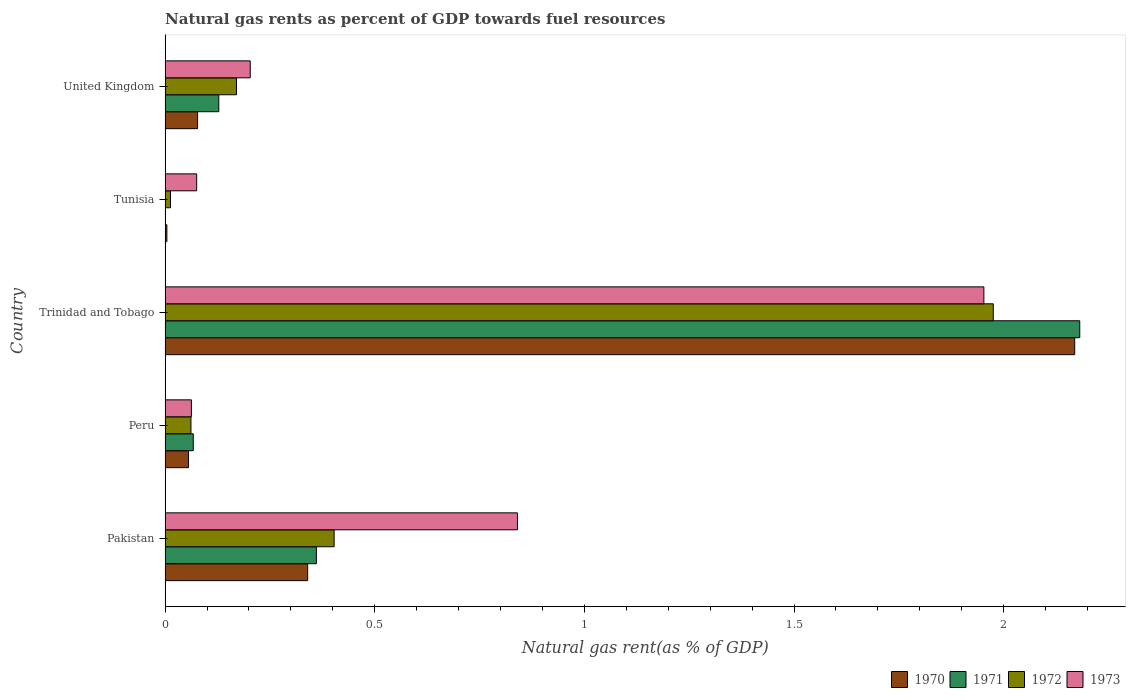How many different coloured bars are there?
Give a very brief answer. 4. How many bars are there on the 3rd tick from the top?
Make the answer very short. 4. How many bars are there on the 1st tick from the bottom?
Offer a very short reply. 4. What is the label of the 2nd group of bars from the top?
Your answer should be compact. Tunisia. What is the natural gas rent in 1971 in Peru?
Your response must be concise. 0.07. Across all countries, what is the maximum natural gas rent in 1973?
Your response must be concise. 1.95. Across all countries, what is the minimum natural gas rent in 1973?
Give a very brief answer. 0.06. In which country was the natural gas rent in 1971 maximum?
Provide a short and direct response. Trinidad and Tobago. In which country was the natural gas rent in 1972 minimum?
Offer a very short reply. Tunisia. What is the total natural gas rent in 1972 in the graph?
Provide a short and direct response. 2.62. What is the difference between the natural gas rent in 1972 in Peru and that in United Kingdom?
Offer a very short reply. -0.11. What is the difference between the natural gas rent in 1971 in Tunisia and the natural gas rent in 1972 in Peru?
Your response must be concise. -0.06. What is the average natural gas rent in 1973 per country?
Provide a short and direct response. 0.63. What is the difference between the natural gas rent in 1972 and natural gas rent in 1971 in Peru?
Ensure brevity in your answer.  -0.01. In how many countries, is the natural gas rent in 1971 greater than 0.9 %?
Provide a short and direct response. 1. What is the ratio of the natural gas rent in 1971 in Pakistan to that in Trinidad and Tobago?
Ensure brevity in your answer.  0.17. Is the difference between the natural gas rent in 1972 in Pakistan and Peru greater than the difference between the natural gas rent in 1971 in Pakistan and Peru?
Offer a terse response. Yes. What is the difference between the highest and the second highest natural gas rent in 1971?
Keep it short and to the point. 1.82. What is the difference between the highest and the lowest natural gas rent in 1970?
Offer a terse response. 2.17. In how many countries, is the natural gas rent in 1970 greater than the average natural gas rent in 1970 taken over all countries?
Provide a succinct answer. 1. Does the graph contain grids?
Provide a succinct answer. No. How many legend labels are there?
Make the answer very short. 4. How are the legend labels stacked?
Offer a terse response. Horizontal. What is the title of the graph?
Your response must be concise. Natural gas rents as percent of GDP towards fuel resources. What is the label or title of the X-axis?
Your answer should be compact. Natural gas rent(as % of GDP). What is the label or title of the Y-axis?
Provide a short and direct response. Country. What is the Natural gas rent(as % of GDP) of 1970 in Pakistan?
Keep it short and to the point. 0.34. What is the Natural gas rent(as % of GDP) of 1971 in Pakistan?
Make the answer very short. 0.36. What is the Natural gas rent(as % of GDP) in 1972 in Pakistan?
Give a very brief answer. 0.4. What is the Natural gas rent(as % of GDP) of 1973 in Pakistan?
Make the answer very short. 0.84. What is the Natural gas rent(as % of GDP) of 1970 in Peru?
Provide a succinct answer. 0.06. What is the Natural gas rent(as % of GDP) in 1971 in Peru?
Offer a very short reply. 0.07. What is the Natural gas rent(as % of GDP) in 1972 in Peru?
Offer a terse response. 0.06. What is the Natural gas rent(as % of GDP) in 1973 in Peru?
Your answer should be very brief. 0.06. What is the Natural gas rent(as % of GDP) in 1970 in Trinidad and Tobago?
Provide a succinct answer. 2.17. What is the Natural gas rent(as % of GDP) of 1971 in Trinidad and Tobago?
Your answer should be compact. 2.18. What is the Natural gas rent(as % of GDP) of 1972 in Trinidad and Tobago?
Your response must be concise. 1.98. What is the Natural gas rent(as % of GDP) of 1973 in Trinidad and Tobago?
Your answer should be compact. 1.95. What is the Natural gas rent(as % of GDP) in 1970 in Tunisia?
Provide a succinct answer. 0. What is the Natural gas rent(as % of GDP) of 1971 in Tunisia?
Your answer should be very brief. 0. What is the Natural gas rent(as % of GDP) in 1972 in Tunisia?
Your response must be concise. 0.01. What is the Natural gas rent(as % of GDP) of 1973 in Tunisia?
Give a very brief answer. 0.08. What is the Natural gas rent(as % of GDP) in 1970 in United Kingdom?
Your response must be concise. 0.08. What is the Natural gas rent(as % of GDP) in 1971 in United Kingdom?
Your answer should be very brief. 0.13. What is the Natural gas rent(as % of GDP) in 1972 in United Kingdom?
Provide a succinct answer. 0.17. What is the Natural gas rent(as % of GDP) in 1973 in United Kingdom?
Keep it short and to the point. 0.2. Across all countries, what is the maximum Natural gas rent(as % of GDP) in 1970?
Your answer should be compact. 2.17. Across all countries, what is the maximum Natural gas rent(as % of GDP) of 1971?
Offer a very short reply. 2.18. Across all countries, what is the maximum Natural gas rent(as % of GDP) of 1972?
Your answer should be very brief. 1.98. Across all countries, what is the maximum Natural gas rent(as % of GDP) of 1973?
Offer a terse response. 1.95. Across all countries, what is the minimum Natural gas rent(as % of GDP) in 1970?
Your answer should be compact. 0. Across all countries, what is the minimum Natural gas rent(as % of GDP) of 1971?
Offer a very short reply. 0. Across all countries, what is the minimum Natural gas rent(as % of GDP) of 1972?
Your answer should be very brief. 0.01. Across all countries, what is the minimum Natural gas rent(as % of GDP) in 1973?
Offer a very short reply. 0.06. What is the total Natural gas rent(as % of GDP) in 1970 in the graph?
Give a very brief answer. 2.65. What is the total Natural gas rent(as % of GDP) of 1971 in the graph?
Give a very brief answer. 2.74. What is the total Natural gas rent(as % of GDP) of 1972 in the graph?
Offer a very short reply. 2.62. What is the total Natural gas rent(as % of GDP) of 1973 in the graph?
Your response must be concise. 3.13. What is the difference between the Natural gas rent(as % of GDP) in 1970 in Pakistan and that in Peru?
Give a very brief answer. 0.28. What is the difference between the Natural gas rent(as % of GDP) in 1971 in Pakistan and that in Peru?
Your answer should be compact. 0.29. What is the difference between the Natural gas rent(as % of GDP) in 1972 in Pakistan and that in Peru?
Make the answer very short. 0.34. What is the difference between the Natural gas rent(as % of GDP) of 1973 in Pakistan and that in Peru?
Give a very brief answer. 0.78. What is the difference between the Natural gas rent(as % of GDP) of 1970 in Pakistan and that in Trinidad and Tobago?
Your answer should be very brief. -1.83. What is the difference between the Natural gas rent(as % of GDP) of 1971 in Pakistan and that in Trinidad and Tobago?
Offer a terse response. -1.82. What is the difference between the Natural gas rent(as % of GDP) of 1972 in Pakistan and that in Trinidad and Tobago?
Give a very brief answer. -1.57. What is the difference between the Natural gas rent(as % of GDP) in 1973 in Pakistan and that in Trinidad and Tobago?
Offer a very short reply. -1.11. What is the difference between the Natural gas rent(as % of GDP) in 1970 in Pakistan and that in Tunisia?
Your response must be concise. 0.34. What is the difference between the Natural gas rent(as % of GDP) of 1971 in Pakistan and that in Tunisia?
Your answer should be very brief. 0.36. What is the difference between the Natural gas rent(as % of GDP) in 1972 in Pakistan and that in Tunisia?
Ensure brevity in your answer.  0.39. What is the difference between the Natural gas rent(as % of GDP) in 1973 in Pakistan and that in Tunisia?
Your answer should be very brief. 0.77. What is the difference between the Natural gas rent(as % of GDP) in 1970 in Pakistan and that in United Kingdom?
Your answer should be very brief. 0.26. What is the difference between the Natural gas rent(as % of GDP) in 1971 in Pakistan and that in United Kingdom?
Your response must be concise. 0.23. What is the difference between the Natural gas rent(as % of GDP) in 1972 in Pakistan and that in United Kingdom?
Give a very brief answer. 0.23. What is the difference between the Natural gas rent(as % of GDP) of 1973 in Pakistan and that in United Kingdom?
Your answer should be compact. 0.64. What is the difference between the Natural gas rent(as % of GDP) of 1970 in Peru and that in Trinidad and Tobago?
Offer a very short reply. -2.11. What is the difference between the Natural gas rent(as % of GDP) of 1971 in Peru and that in Trinidad and Tobago?
Keep it short and to the point. -2.11. What is the difference between the Natural gas rent(as % of GDP) in 1972 in Peru and that in Trinidad and Tobago?
Provide a succinct answer. -1.91. What is the difference between the Natural gas rent(as % of GDP) of 1973 in Peru and that in Trinidad and Tobago?
Keep it short and to the point. -1.89. What is the difference between the Natural gas rent(as % of GDP) of 1970 in Peru and that in Tunisia?
Your answer should be compact. 0.05. What is the difference between the Natural gas rent(as % of GDP) in 1971 in Peru and that in Tunisia?
Ensure brevity in your answer.  0.07. What is the difference between the Natural gas rent(as % of GDP) in 1972 in Peru and that in Tunisia?
Ensure brevity in your answer.  0.05. What is the difference between the Natural gas rent(as % of GDP) of 1973 in Peru and that in Tunisia?
Give a very brief answer. -0.01. What is the difference between the Natural gas rent(as % of GDP) in 1970 in Peru and that in United Kingdom?
Provide a short and direct response. -0.02. What is the difference between the Natural gas rent(as % of GDP) in 1971 in Peru and that in United Kingdom?
Keep it short and to the point. -0.06. What is the difference between the Natural gas rent(as % of GDP) in 1972 in Peru and that in United Kingdom?
Make the answer very short. -0.11. What is the difference between the Natural gas rent(as % of GDP) of 1973 in Peru and that in United Kingdom?
Provide a short and direct response. -0.14. What is the difference between the Natural gas rent(as % of GDP) in 1970 in Trinidad and Tobago and that in Tunisia?
Ensure brevity in your answer.  2.17. What is the difference between the Natural gas rent(as % of GDP) in 1971 in Trinidad and Tobago and that in Tunisia?
Your answer should be compact. 2.18. What is the difference between the Natural gas rent(as % of GDP) in 1972 in Trinidad and Tobago and that in Tunisia?
Your response must be concise. 1.96. What is the difference between the Natural gas rent(as % of GDP) in 1973 in Trinidad and Tobago and that in Tunisia?
Give a very brief answer. 1.88. What is the difference between the Natural gas rent(as % of GDP) of 1970 in Trinidad and Tobago and that in United Kingdom?
Give a very brief answer. 2.09. What is the difference between the Natural gas rent(as % of GDP) of 1971 in Trinidad and Tobago and that in United Kingdom?
Give a very brief answer. 2.05. What is the difference between the Natural gas rent(as % of GDP) in 1972 in Trinidad and Tobago and that in United Kingdom?
Your response must be concise. 1.8. What is the difference between the Natural gas rent(as % of GDP) in 1973 in Trinidad and Tobago and that in United Kingdom?
Ensure brevity in your answer.  1.75. What is the difference between the Natural gas rent(as % of GDP) in 1970 in Tunisia and that in United Kingdom?
Offer a terse response. -0.07. What is the difference between the Natural gas rent(as % of GDP) of 1971 in Tunisia and that in United Kingdom?
Your answer should be compact. -0.13. What is the difference between the Natural gas rent(as % of GDP) in 1972 in Tunisia and that in United Kingdom?
Your response must be concise. -0.16. What is the difference between the Natural gas rent(as % of GDP) of 1973 in Tunisia and that in United Kingdom?
Give a very brief answer. -0.13. What is the difference between the Natural gas rent(as % of GDP) in 1970 in Pakistan and the Natural gas rent(as % of GDP) in 1971 in Peru?
Your answer should be very brief. 0.27. What is the difference between the Natural gas rent(as % of GDP) of 1970 in Pakistan and the Natural gas rent(as % of GDP) of 1972 in Peru?
Provide a succinct answer. 0.28. What is the difference between the Natural gas rent(as % of GDP) of 1970 in Pakistan and the Natural gas rent(as % of GDP) of 1973 in Peru?
Make the answer very short. 0.28. What is the difference between the Natural gas rent(as % of GDP) in 1971 in Pakistan and the Natural gas rent(as % of GDP) in 1972 in Peru?
Provide a succinct answer. 0.3. What is the difference between the Natural gas rent(as % of GDP) in 1971 in Pakistan and the Natural gas rent(as % of GDP) in 1973 in Peru?
Your answer should be very brief. 0.3. What is the difference between the Natural gas rent(as % of GDP) of 1972 in Pakistan and the Natural gas rent(as % of GDP) of 1973 in Peru?
Keep it short and to the point. 0.34. What is the difference between the Natural gas rent(as % of GDP) of 1970 in Pakistan and the Natural gas rent(as % of GDP) of 1971 in Trinidad and Tobago?
Give a very brief answer. -1.84. What is the difference between the Natural gas rent(as % of GDP) in 1970 in Pakistan and the Natural gas rent(as % of GDP) in 1972 in Trinidad and Tobago?
Offer a terse response. -1.64. What is the difference between the Natural gas rent(as % of GDP) in 1970 in Pakistan and the Natural gas rent(as % of GDP) in 1973 in Trinidad and Tobago?
Ensure brevity in your answer.  -1.61. What is the difference between the Natural gas rent(as % of GDP) of 1971 in Pakistan and the Natural gas rent(as % of GDP) of 1972 in Trinidad and Tobago?
Offer a terse response. -1.61. What is the difference between the Natural gas rent(as % of GDP) in 1971 in Pakistan and the Natural gas rent(as % of GDP) in 1973 in Trinidad and Tobago?
Keep it short and to the point. -1.59. What is the difference between the Natural gas rent(as % of GDP) in 1972 in Pakistan and the Natural gas rent(as % of GDP) in 1973 in Trinidad and Tobago?
Your response must be concise. -1.55. What is the difference between the Natural gas rent(as % of GDP) of 1970 in Pakistan and the Natural gas rent(as % of GDP) of 1971 in Tunisia?
Offer a terse response. 0.34. What is the difference between the Natural gas rent(as % of GDP) of 1970 in Pakistan and the Natural gas rent(as % of GDP) of 1972 in Tunisia?
Ensure brevity in your answer.  0.33. What is the difference between the Natural gas rent(as % of GDP) of 1970 in Pakistan and the Natural gas rent(as % of GDP) of 1973 in Tunisia?
Your response must be concise. 0.26. What is the difference between the Natural gas rent(as % of GDP) of 1971 in Pakistan and the Natural gas rent(as % of GDP) of 1972 in Tunisia?
Give a very brief answer. 0.35. What is the difference between the Natural gas rent(as % of GDP) of 1971 in Pakistan and the Natural gas rent(as % of GDP) of 1973 in Tunisia?
Your response must be concise. 0.29. What is the difference between the Natural gas rent(as % of GDP) in 1972 in Pakistan and the Natural gas rent(as % of GDP) in 1973 in Tunisia?
Your answer should be very brief. 0.33. What is the difference between the Natural gas rent(as % of GDP) in 1970 in Pakistan and the Natural gas rent(as % of GDP) in 1971 in United Kingdom?
Make the answer very short. 0.21. What is the difference between the Natural gas rent(as % of GDP) of 1970 in Pakistan and the Natural gas rent(as % of GDP) of 1972 in United Kingdom?
Your answer should be very brief. 0.17. What is the difference between the Natural gas rent(as % of GDP) of 1970 in Pakistan and the Natural gas rent(as % of GDP) of 1973 in United Kingdom?
Offer a terse response. 0.14. What is the difference between the Natural gas rent(as % of GDP) in 1971 in Pakistan and the Natural gas rent(as % of GDP) in 1972 in United Kingdom?
Ensure brevity in your answer.  0.19. What is the difference between the Natural gas rent(as % of GDP) in 1971 in Pakistan and the Natural gas rent(as % of GDP) in 1973 in United Kingdom?
Offer a very short reply. 0.16. What is the difference between the Natural gas rent(as % of GDP) of 1972 in Pakistan and the Natural gas rent(as % of GDP) of 1973 in United Kingdom?
Your answer should be very brief. 0.2. What is the difference between the Natural gas rent(as % of GDP) of 1970 in Peru and the Natural gas rent(as % of GDP) of 1971 in Trinidad and Tobago?
Provide a short and direct response. -2.13. What is the difference between the Natural gas rent(as % of GDP) of 1970 in Peru and the Natural gas rent(as % of GDP) of 1972 in Trinidad and Tobago?
Keep it short and to the point. -1.92. What is the difference between the Natural gas rent(as % of GDP) of 1970 in Peru and the Natural gas rent(as % of GDP) of 1973 in Trinidad and Tobago?
Offer a very short reply. -1.9. What is the difference between the Natural gas rent(as % of GDP) in 1971 in Peru and the Natural gas rent(as % of GDP) in 1972 in Trinidad and Tobago?
Keep it short and to the point. -1.91. What is the difference between the Natural gas rent(as % of GDP) of 1971 in Peru and the Natural gas rent(as % of GDP) of 1973 in Trinidad and Tobago?
Ensure brevity in your answer.  -1.89. What is the difference between the Natural gas rent(as % of GDP) of 1972 in Peru and the Natural gas rent(as % of GDP) of 1973 in Trinidad and Tobago?
Give a very brief answer. -1.89. What is the difference between the Natural gas rent(as % of GDP) of 1970 in Peru and the Natural gas rent(as % of GDP) of 1971 in Tunisia?
Your answer should be compact. 0.06. What is the difference between the Natural gas rent(as % of GDP) of 1970 in Peru and the Natural gas rent(as % of GDP) of 1972 in Tunisia?
Give a very brief answer. 0.04. What is the difference between the Natural gas rent(as % of GDP) in 1970 in Peru and the Natural gas rent(as % of GDP) in 1973 in Tunisia?
Give a very brief answer. -0.02. What is the difference between the Natural gas rent(as % of GDP) in 1971 in Peru and the Natural gas rent(as % of GDP) in 1972 in Tunisia?
Offer a very short reply. 0.05. What is the difference between the Natural gas rent(as % of GDP) of 1971 in Peru and the Natural gas rent(as % of GDP) of 1973 in Tunisia?
Provide a short and direct response. -0.01. What is the difference between the Natural gas rent(as % of GDP) in 1972 in Peru and the Natural gas rent(as % of GDP) in 1973 in Tunisia?
Offer a terse response. -0.01. What is the difference between the Natural gas rent(as % of GDP) of 1970 in Peru and the Natural gas rent(as % of GDP) of 1971 in United Kingdom?
Your answer should be very brief. -0.07. What is the difference between the Natural gas rent(as % of GDP) in 1970 in Peru and the Natural gas rent(as % of GDP) in 1972 in United Kingdom?
Make the answer very short. -0.11. What is the difference between the Natural gas rent(as % of GDP) in 1970 in Peru and the Natural gas rent(as % of GDP) in 1973 in United Kingdom?
Provide a succinct answer. -0.15. What is the difference between the Natural gas rent(as % of GDP) in 1971 in Peru and the Natural gas rent(as % of GDP) in 1972 in United Kingdom?
Offer a terse response. -0.1. What is the difference between the Natural gas rent(as % of GDP) in 1971 in Peru and the Natural gas rent(as % of GDP) in 1973 in United Kingdom?
Give a very brief answer. -0.14. What is the difference between the Natural gas rent(as % of GDP) in 1972 in Peru and the Natural gas rent(as % of GDP) in 1973 in United Kingdom?
Make the answer very short. -0.14. What is the difference between the Natural gas rent(as % of GDP) in 1970 in Trinidad and Tobago and the Natural gas rent(as % of GDP) in 1971 in Tunisia?
Provide a succinct answer. 2.17. What is the difference between the Natural gas rent(as % of GDP) of 1970 in Trinidad and Tobago and the Natural gas rent(as % of GDP) of 1972 in Tunisia?
Keep it short and to the point. 2.16. What is the difference between the Natural gas rent(as % of GDP) in 1970 in Trinidad and Tobago and the Natural gas rent(as % of GDP) in 1973 in Tunisia?
Offer a very short reply. 2.09. What is the difference between the Natural gas rent(as % of GDP) in 1971 in Trinidad and Tobago and the Natural gas rent(as % of GDP) in 1972 in Tunisia?
Your response must be concise. 2.17. What is the difference between the Natural gas rent(as % of GDP) in 1971 in Trinidad and Tobago and the Natural gas rent(as % of GDP) in 1973 in Tunisia?
Provide a short and direct response. 2.11. What is the difference between the Natural gas rent(as % of GDP) of 1972 in Trinidad and Tobago and the Natural gas rent(as % of GDP) of 1973 in Tunisia?
Your answer should be very brief. 1.9. What is the difference between the Natural gas rent(as % of GDP) in 1970 in Trinidad and Tobago and the Natural gas rent(as % of GDP) in 1971 in United Kingdom?
Provide a succinct answer. 2.04. What is the difference between the Natural gas rent(as % of GDP) in 1970 in Trinidad and Tobago and the Natural gas rent(as % of GDP) in 1972 in United Kingdom?
Your response must be concise. 2. What is the difference between the Natural gas rent(as % of GDP) of 1970 in Trinidad and Tobago and the Natural gas rent(as % of GDP) of 1973 in United Kingdom?
Offer a terse response. 1.97. What is the difference between the Natural gas rent(as % of GDP) of 1971 in Trinidad and Tobago and the Natural gas rent(as % of GDP) of 1972 in United Kingdom?
Ensure brevity in your answer.  2.01. What is the difference between the Natural gas rent(as % of GDP) in 1971 in Trinidad and Tobago and the Natural gas rent(as % of GDP) in 1973 in United Kingdom?
Offer a very short reply. 1.98. What is the difference between the Natural gas rent(as % of GDP) in 1972 in Trinidad and Tobago and the Natural gas rent(as % of GDP) in 1973 in United Kingdom?
Your response must be concise. 1.77. What is the difference between the Natural gas rent(as % of GDP) in 1970 in Tunisia and the Natural gas rent(as % of GDP) in 1971 in United Kingdom?
Keep it short and to the point. -0.12. What is the difference between the Natural gas rent(as % of GDP) in 1970 in Tunisia and the Natural gas rent(as % of GDP) in 1972 in United Kingdom?
Ensure brevity in your answer.  -0.17. What is the difference between the Natural gas rent(as % of GDP) in 1970 in Tunisia and the Natural gas rent(as % of GDP) in 1973 in United Kingdom?
Your response must be concise. -0.2. What is the difference between the Natural gas rent(as % of GDP) of 1971 in Tunisia and the Natural gas rent(as % of GDP) of 1972 in United Kingdom?
Keep it short and to the point. -0.17. What is the difference between the Natural gas rent(as % of GDP) of 1971 in Tunisia and the Natural gas rent(as % of GDP) of 1973 in United Kingdom?
Your answer should be very brief. -0.2. What is the difference between the Natural gas rent(as % of GDP) of 1972 in Tunisia and the Natural gas rent(as % of GDP) of 1973 in United Kingdom?
Your response must be concise. -0.19. What is the average Natural gas rent(as % of GDP) of 1970 per country?
Your answer should be very brief. 0.53. What is the average Natural gas rent(as % of GDP) of 1971 per country?
Your response must be concise. 0.55. What is the average Natural gas rent(as % of GDP) of 1972 per country?
Your answer should be very brief. 0.52. What is the average Natural gas rent(as % of GDP) in 1973 per country?
Make the answer very short. 0.63. What is the difference between the Natural gas rent(as % of GDP) of 1970 and Natural gas rent(as % of GDP) of 1971 in Pakistan?
Give a very brief answer. -0.02. What is the difference between the Natural gas rent(as % of GDP) in 1970 and Natural gas rent(as % of GDP) in 1972 in Pakistan?
Offer a terse response. -0.06. What is the difference between the Natural gas rent(as % of GDP) in 1970 and Natural gas rent(as % of GDP) in 1973 in Pakistan?
Provide a short and direct response. -0.5. What is the difference between the Natural gas rent(as % of GDP) of 1971 and Natural gas rent(as % of GDP) of 1972 in Pakistan?
Keep it short and to the point. -0.04. What is the difference between the Natural gas rent(as % of GDP) in 1971 and Natural gas rent(as % of GDP) in 1973 in Pakistan?
Your answer should be very brief. -0.48. What is the difference between the Natural gas rent(as % of GDP) in 1972 and Natural gas rent(as % of GDP) in 1973 in Pakistan?
Offer a terse response. -0.44. What is the difference between the Natural gas rent(as % of GDP) in 1970 and Natural gas rent(as % of GDP) in 1971 in Peru?
Give a very brief answer. -0.01. What is the difference between the Natural gas rent(as % of GDP) of 1970 and Natural gas rent(as % of GDP) of 1972 in Peru?
Offer a very short reply. -0.01. What is the difference between the Natural gas rent(as % of GDP) in 1970 and Natural gas rent(as % of GDP) in 1973 in Peru?
Ensure brevity in your answer.  -0.01. What is the difference between the Natural gas rent(as % of GDP) of 1971 and Natural gas rent(as % of GDP) of 1972 in Peru?
Keep it short and to the point. 0.01. What is the difference between the Natural gas rent(as % of GDP) of 1971 and Natural gas rent(as % of GDP) of 1973 in Peru?
Your response must be concise. 0. What is the difference between the Natural gas rent(as % of GDP) of 1972 and Natural gas rent(as % of GDP) of 1973 in Peru?
Keep it short and to the point. -0. What is the difference between the Natural gas rent(as % of GDP) in 1970 and Natural gas rent(as % of GDP) in 1971 in Trinidad and Tobago?
Make the answer very short. -0.01. What is the difference between the Natural gas rent(as % of GDP) in 1970 and Natural gas rent(as % of GDP) in 1972 in Trinidad and Tobago?
Keep it short and to the point. 0.19. What is the difference between the Natural gas rent(as % of GDP) of 1970 and Natural gas rent(as % of GDP) of 1973 in Trinidad and Tobago?
Offer a terse response. 0.22. What is the difference between the Natural gas rent(as % of GDP) of 1971 and Natural gas rent(as % of GDP) of 1972 in Trinidad and Tobago?
Keep it short and to the point. 0.21. What is the difference between the Natural gas rent(as % of GDP) in 1971 and Natural gas rent(as % of GDP) in 1973 in Trinidad and Tobago?
Make the answer very short. 0.23. What is the difference between the Natural gas rent(as % of GDP) in 1972 and Natural gas rent(as % of GDP) in 1973 in Trinidad and Tobago?
Your response must be concise. 0.02. What is the difference between the Natural gas rent(as % of GDP) in 1970 and Natural gas rent(as % of GDP) in 1971 in Tunisia?
Ensure brevity in your answer.  0. What is the difference between the Natural gas rent(as % of GDP) in 1970 and Natural gas rent(as % of GDP) in 1972 in Tunisia?
Your answer should be very brief. -0.01. What is the difference between the Natural gas rent(as % of GDP) in 1970 and Natural gas rent(as % of GDP) in 1973 in Tunisia?
Your answer should be compact. -0.07. What is the difference between the Natural gas rent(as % of GDP) of 1971 and Natural gas rent(as % of GDP) of 1972 in Tunisia?
Offer a very short reply. -0.01. What is the difference between the Natural gas rent(as % of GDP) of 1971 and Natural gas rent(as % of GDP) of 1973 in Tunisia?
Make the answer very short. -0.07. What is the difference between the Natural gas rent(as % of GDP) of 1972 and Natural gas rent(as % of GDP) of 1973 in Tunisia?
Your answer should be compact. -0.06. What is the difference between the Natural gas rent(as % of GDP) in 1970 and Natural gas rent(as % of GDP) in 1971 in United Kingdom?
Give a very brief answer. -0.05. What is the difference between the Natural gas rent(as % of GDP) of 1970 and Natural gas rent(as % of GDP) of 1972 in United Kingdom?
Your answer should be compact. -0.09. What is the difference between the Natural gas rent(as % of GDP) in 1970 and Natural gas rent(as % of GDP) in 1973 in United Kingdom?
Your answer should be compact. -0.13. What is the difference between the Natural gas rent(as % of GDP) in 1971 and Natural gas rent(as % of GDP) in 1972 in United Kingdom?
Give a very brief answer. -0.04. What is the difference between the Natural gas rent(as % of GDP) in 1971 and Natural gas rent(as % of GDP) in 1973 in United Kingdom?
Ensure brevity in your answer.  -0.07. What is the difference between the Natural gas rent(as % of GDP) in 1972 and Natural gas rent(as % of GDP) in 1973 in United Kingdom?
Your response must be concise. -0.03. What is the ratio of the Natural gas rent(as % of GDP) of 1970 in Pakistan to that in Peru?
Offer a terse response. 6.1. What is the ratio of the Natural gas rent(as % of GDP) in 1971 in Pakistan to that in Peru?
Your answer should be compact. 5.37. What is the ratio of the Natural gas rent(as % of GDP) in 1972 in Pakistan to that in Peru?
Keep it short and to the point. 6.54. What is the ratio of the Natural gas rent(as % of GDP) of 1973 in Pakistan to that in Peru?
Provide a succinct answer. 13.39. What is the ratio of the Natural gas rent(as % of GDP) in 1970 in Pakistan to that in Trinidad and Tobago?
Keep it short and to the point. 0.16. What is the ratio of the Natural gas rent(as % of GDP) of 1971 in Pakistan to that in Trinidad and Tobago?
Provide a short and direct response. 0.17. What is the ratio of the Natural gas rent(as % of GDP) of 1972 in Pakistan to that in Trinidad and Tobago?
Your answer should be very brief. 0.2. What is the ratio of the Natural gas rent(as % of GDP) of 1973 in Pakistan to that in Trinidad and Tobago?
Offer a very short reply. 0.43. What is the ratio of the Natural gas rent(as % of GDP) of 1970 in Pakistan to that in Tunisia?
Provide a short and direct response. 80.16. What is the ratio of the Natural gas rent(as % of GDP) in 1971 in Pakistan to that in Tunisia?
Provide a succinct answer. 486.4. What is the ratio of the Natural gas rent(as % of GDP) of 1972 in Pakistan to that in Tunisia?
Your answer should be very brief. 31.31. What is the ratio of the Natural gas rent(as % of GDP) of 1973 in Pakistan to that in Tunisia?
Offer a terse response. 11.17. What is the ratio of the Natural gas rent(as % of GDP) in 1970 in Pakistan to that in United Kingdom?
Provide a succinct answer. 4.39. What is the ratio of the Natural gas rent(as % of GDP) of 1971 in Pakistan to that in United Kingdom?
Keep it short and to the point. 2.82. What is the ratio of the Natural gas rent(as % of GDP) of 1972 in Pakistan to that in United Kingdom?
Ensure brevity in your answer.  2.37. What is the ratio of the Natural gas rent(as % of GDP) of 1973 in Pakistan to that in United Kingdom?
Give a very brief answer. 4.14. What is the ratio of the Natural gas rent(as % of GDP) in 1970 in Peru to that in Trinidad and Tobago?
Your answer should be very brief. 0.03. What is the ratio of the Natural gas rent(as % of GDP) in 1971 in Peru to that in Trinidad and Tobago?
Your answer should be compact. 0.03. What is the ratio of the Natural gas rent(as % of GDP) of 1972 in Peru to that in Trinidad and Tobago?
Offer a terse response. 0.03. What is the ratio of the Natural gas rent(as % of GDP) of 1973 in Peru to that in Trinidad and Tobago?
Give a very brief answer. 0.03. What is the ratio of the Natural gas rent(as % of GDP) of 1970 in Peru to that in Tunisia?
Give a very brief answer. 13.15. What is the ratio of the Natural gas rent(as % of GDP) of 1971 in Peru to that in Tunisia?
Make the answer very short. 90.55. What is the ratio of the Natural gas rent(as % of GDP) in 1972 in Peru to that in Tunisia?
Make the answer very short. 4.79. What is the ratio of the Natural gas rent(as % of GDP) in 1973 in Peru to that in Tunisia?
Offer a very short reply. 0.83. What is the ratio of the Natural gas rent(as % of GDP) of 1970 in Peru to that in United Kingdom?
Your answer should be compact. 0.72. What is the ratio of the Natural gas rent(as % of GDP) of 1971 in Peru to that in United Kingdom?
Your answer should be very brief. 0.52. What is the ratio of the Natural gas rent(as % of GDP) of 1972 in Peru to that in United Kingdom?
Your response must be concise. 0.36. What is the ratio of the Natural gas rent(as % of GDP) of 1973 in Peru to that in United Kingdom?
Keep it short and to the point. 0.31. What is the ratio of the Natural gas rent(as % of GDP) in 1970 in Trinidad and Tobago to that in Tunisia?
Make the answer very short. 511.49. What is the ratio of the Natural gas rent(as % of GDP) of 1971 in Trinidad and Tobago to that in Tunisia?
Ensure brevity in your answer.  2940.6. What is the ratio of the Natural gas rent(as % of GDP) of 1972 in Trinidad and Tobago to that in Tunisia?
Keep it short and to the point. 153.39. What is the ratio of the Natural gas rent(as % of GDP) in 1973 in Trinidad and Tobago to that in Tunisia?
Your answer should be compact. 25.94. What is the ratio of the Natural gas rent(as % of GDP) in 1970 in Trinidad and Tobago to that in United Kingdom?
Give a very brief answer. 27.99. What is the ratio of the Natural gas rent(as % of GDP) in 1971 in Trinidad and Tobago to that in United Kingdom?
Offer a terse response. 17.03. What is the ratio of the Natural gas rent(as % of GDP) of 1972 in Trinidad and Tobago to that in United Kingdom?
Your answer should be compact. 11.6. What is the ratio of the Natural gas rent(as % of GDP) of 1973 in Trinidad and Tobago to that in United Kingdom?
Provide a short and direct response. 9.62. What is the ratio of the Natural gas rent(as % of GDP) of 1970 in Tunisia to that in United Kingdom?
Make the answer very short. 0.05. What is the ratio of the Natural gas rent(as % of GDP) of 1971 in Tunisia to that in United Kingdom?
Your answer should be very brief. 0.01. What is the ratio of the Natural gas rent(as % of GDP) in 1972 in Tunisia to that in United Kingdom?
Provide a short and direct response. 0.08. What is the ratio of the Natural gas rent(as % of GDP) in 1973 in Tunisia to that in United Kingdom?
Make the answer very short. 0.37. What is the difference between the highest and the second highest Natural gas rent(as % of GDP) of 1970?
Offer a very short reply. 1.83. What is the difference between the highest and the second highest Natural gas rent(as % of GDP) in 1971?
Offer a very short reply. 1.82. What is the difference between the highest and the second highest Natural gas rent(as % of GDP) in 1972?
Your answer should be very brief. 1.57. What is the difference between the highest and the second highest Natural gas rent(as % of GDP) of 1973?
Give a very brief answer. 1.11. What is the difference between the highest and the lowest Natural gas rent(as % of GDP) in 1970?
Provide a short and direct response. 2.17. What is the difference between the highest and the lowest Natural gas rent(as % of GDP) in 1971?
Keep it short and to the point. 2.18. What is the difference between the highest and the lowest Natural gas rent(as % of GDP) in 1972?
Your answer should be compact. 1.96. What is the difference between the highest and the lowest Natural gas rent(as % of GDP) of 1973?
Keep it short and to the point. 1.89. 